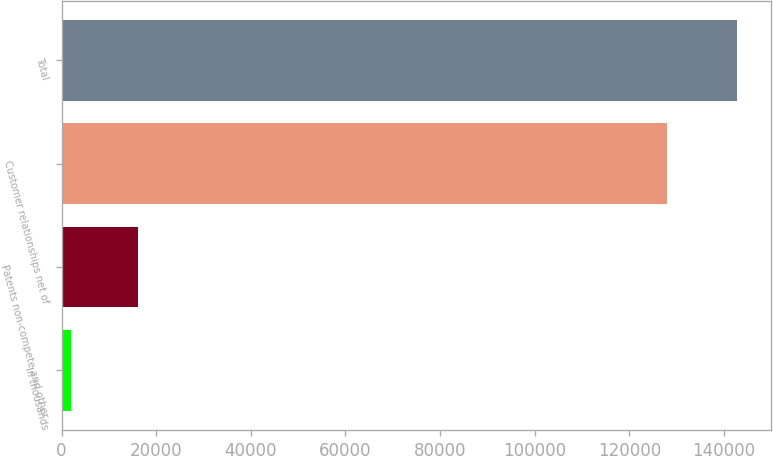Convert chart. <chart><loc_0><loc_0><loc_500><loc_500><bar_chart><fcel>In thousands<fcel>Patents non-compete and other<fcel>Customer relationships net of<fcel>Total<nl><fcel>2011<fcel>16090.8<fcel>127960<fcel>142809<nl></chart> 